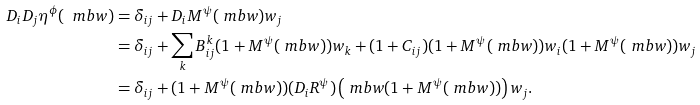<formula> <loc_0><loc_0><loc_500><loc_500>D _ { i } D _ { j } \eta ^ { \phi } ( \ m b { w } ) & = \delta _ { i j } + D _ { i } M ^ { \psi } ( \ m b { w } ) w _ { j } \\ & = \delta _ { i j } + \sum _ { k } B _ { i j } ^ { k } ( 1 + M ^ { \psi } ( \ m b { w } ) ) w _ { k } + ( 1 + C _ { i j } ) ( 1 + M ^ { \psi } ( \ m b { w } ) ) w _ { i } ( 1 + M ^ { \psi } ( \ m b { w } ) ) w _ { j } \\ & = \delta _ { i j } + ( 1 + M ^ { \psi } ( \ m b { w } ) ) ( D _ { i } R ^ { \psi } ) \left ( \ m b { w } ( 1 + M ^ { \psi } ( \ m b { w } ) ) \right ) w _ { j } .</formula> 